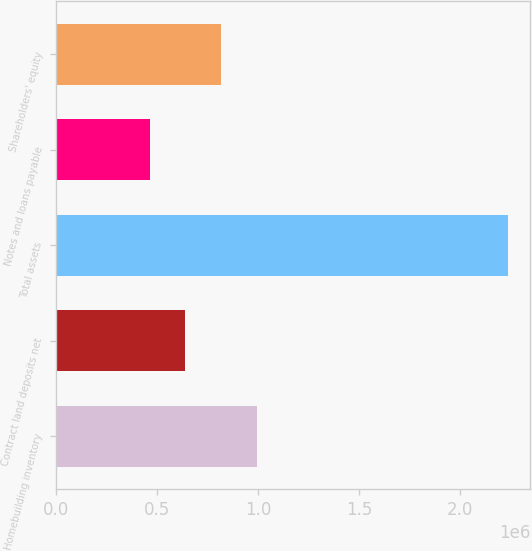<chart> <loc_0><loc_0><loc_500><loc_500><bar_chart><fcel>Homebuilding inventory<fcel>Contract land deposits net<fcel>Total assets<fcel>Notes and loans payable<fcel>Shareholders' equity<nl><fcel>995499<fcel>640594<fcel>2.23767e+06<fcel>463141<fcel>818047<nl></chart> 